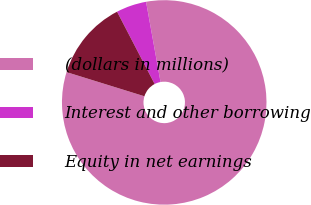<chart> <loc_0><loc_0><loc_500><loc_500><pie_chart><fcel>(dollars in millions)<fcel>Interest and other borrowing<fcel>Equity in net earnings<nl><fcel>82.63%<fcel>4.79%<fcel>12.58%<nl></chart> 